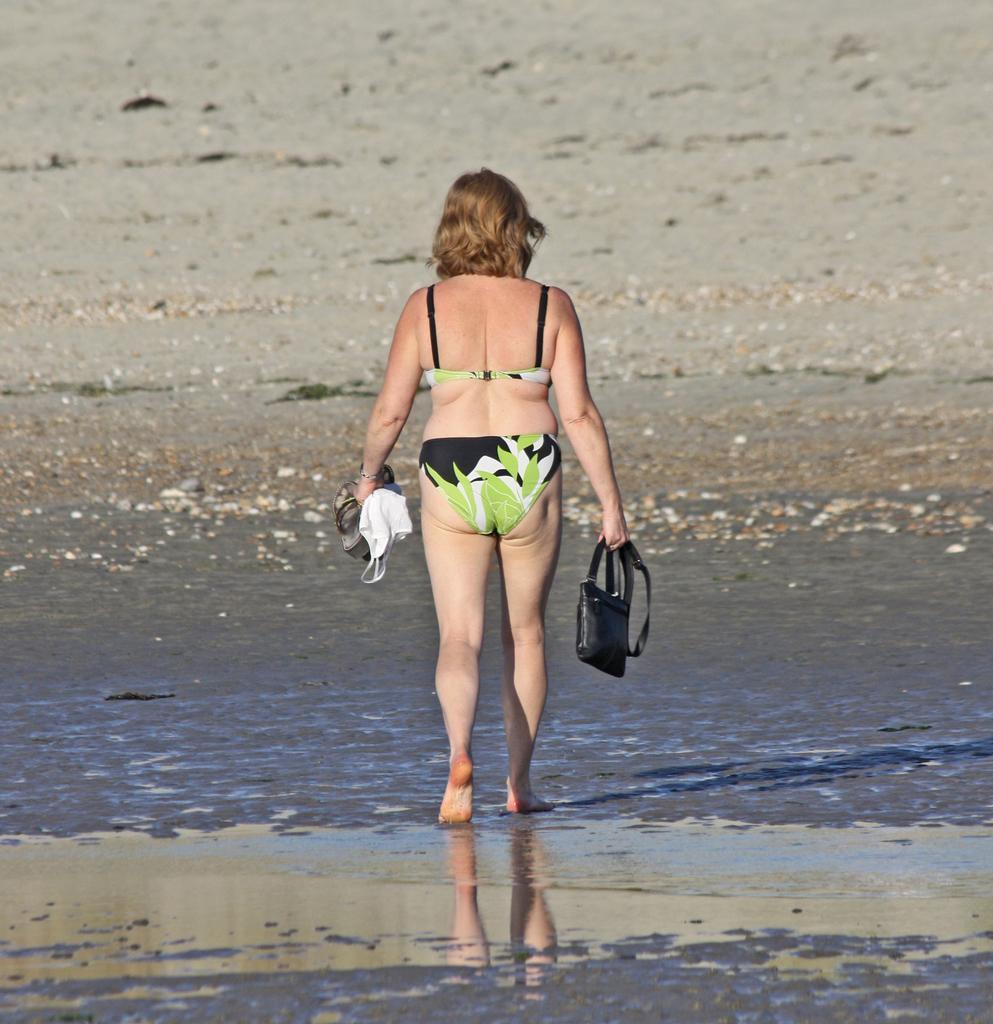Can you describe this image briefly? In this image I can see a person holding the bag and the sandals. 